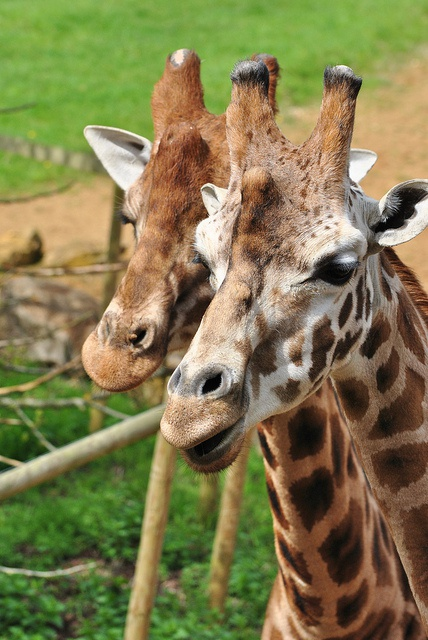Describe the objects in this image and their specific colors. I can see giraffe in olive, black, gray, maroon, and darkgray tones and giraffe in olive, black, gray, and maroon tones in this image. 